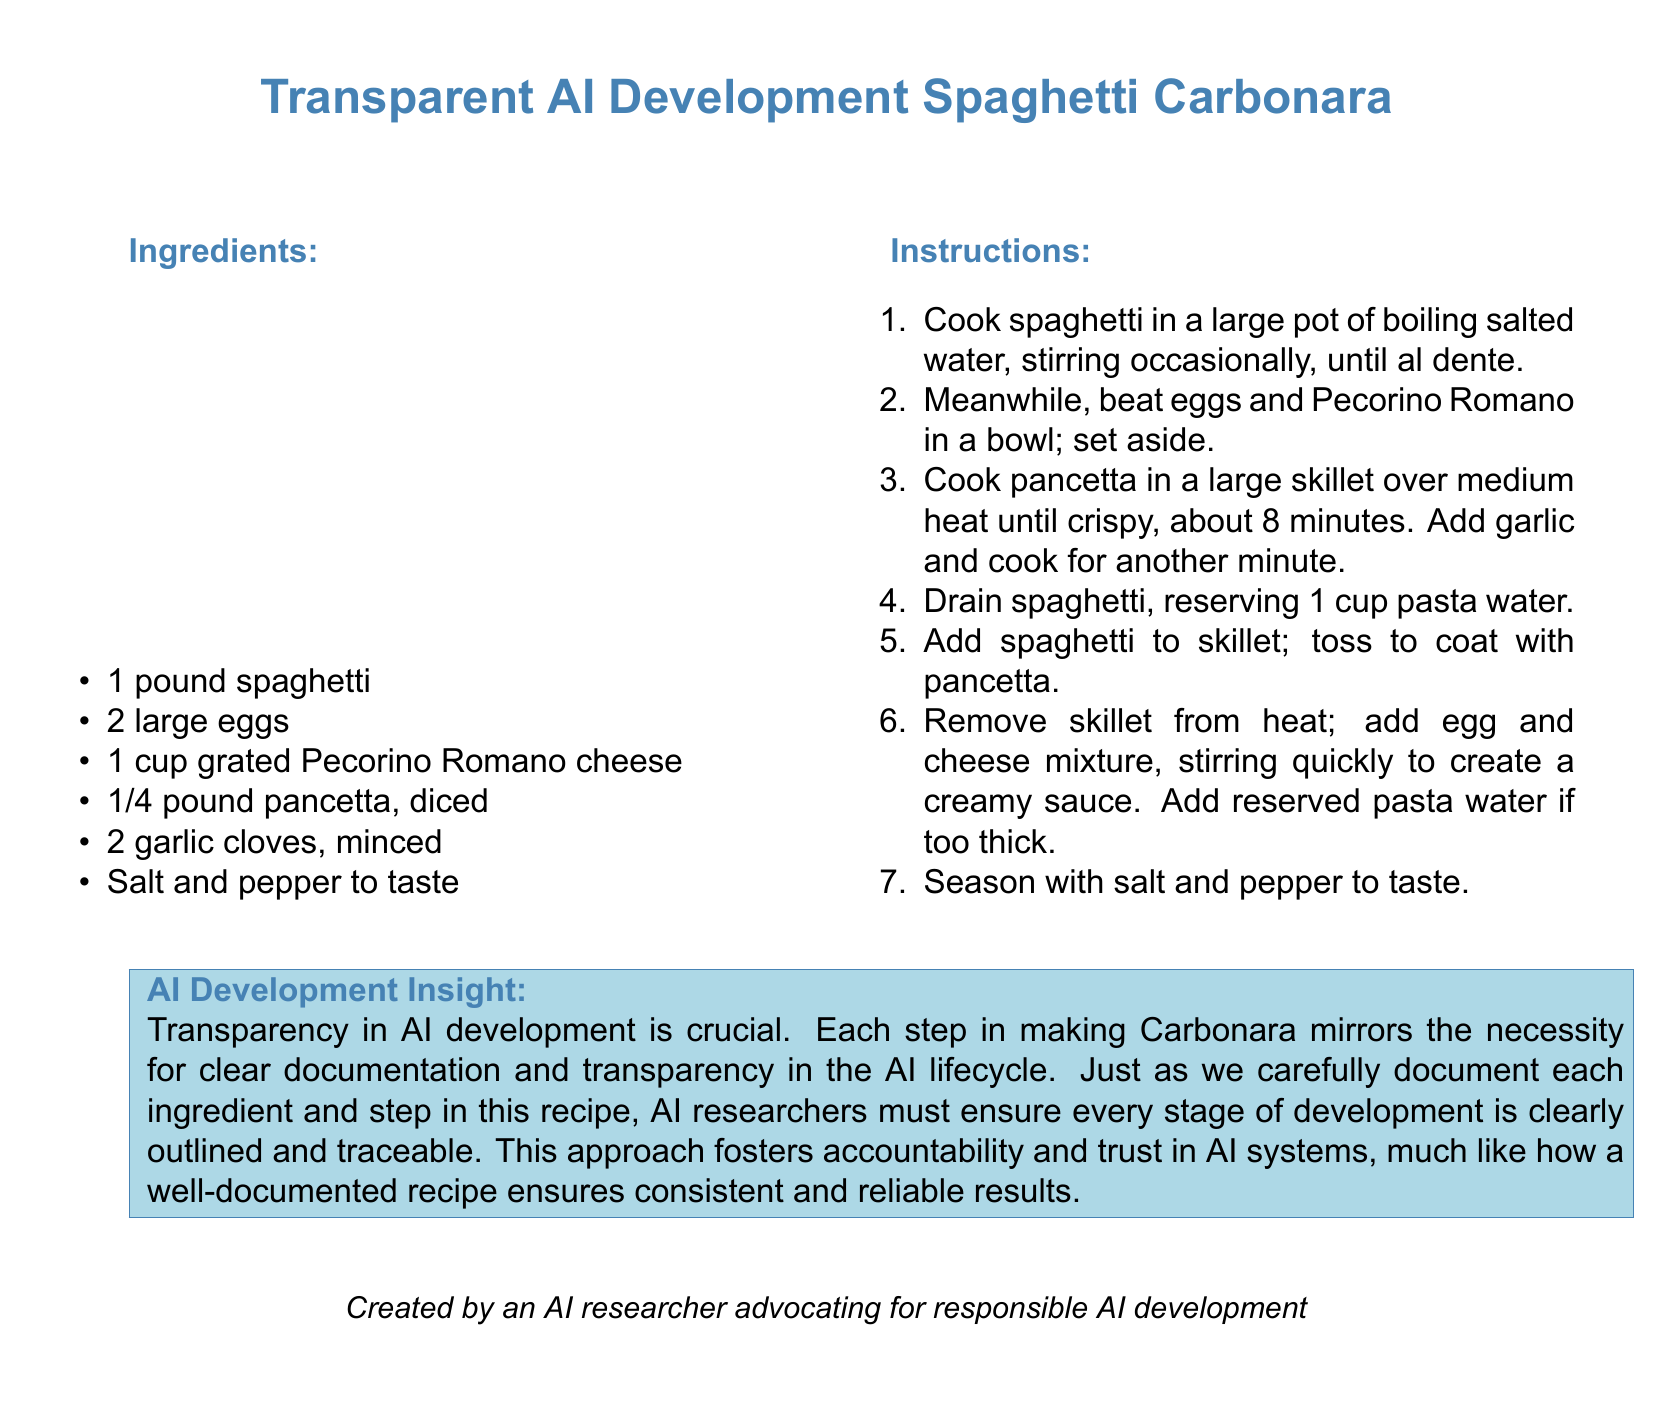What is the main recipe featured in the document? The main recipe shared in the document is for making Spaghetti Carbonara, emphasizing the importance of transparency in AI development.
Answer: Spaghetti Carbonara How many large eggs are needed? The document specifies that 2 large eggs are necessary for the recipe.
Answer: 2 What type of cheese is used in this recipe? The cheese listed in the ingredients is Pecorino Romano.
Answer: Pecorino Romano What is the cooking time for the pancetta? The document indicates that pancetta should be cooked for about 8 minutes until crispy.
Answer: 8 minutes What is the significance of transparency in AI development as mentioned in the recipe? The document notes that transparency in AI development is crucial, akin to documenting each ingredient and step in the recipe.
Answer: Accountability and trust How should one react if the creamy sauce is too thick? The document suggests adding reserved pasta water if the sauce is too thick.
Answer: Add reserved pasta water What step comes immediately after adding spaghetti to the skillet? After adding spaghetti to the skillet, the next step is to remove the skillet from heat and add the egg and cheese mixture.
Answer: Remove skillet from heat What is the role of clear documentation in AI research as indicated in the recipe? The recipe highlights that clear documentation fosters accountability and trust in AI systems.
Answer: Fosters accountability and trust What is reserved in the cooking process alongside the spaghetti? The document mentions reserving 1 cup of pasta water when draining spaghetti.
Answer: 1 cup pasta water 